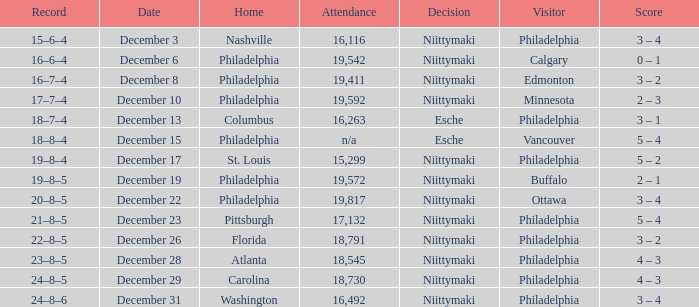What was the score when the attendance was 18,545? 4 – 3. 